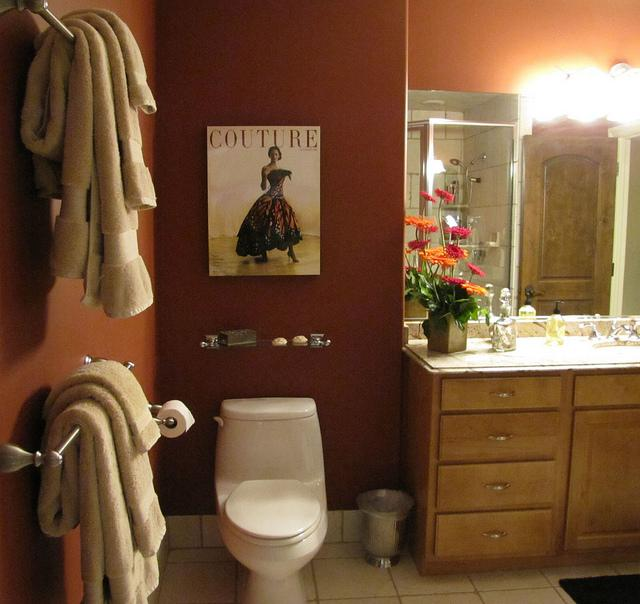What athlete's last name appears on the poster?

Choices:
A) bo jackson
B) randy couture
C) wayne gretzky
D) jim those randy couture 